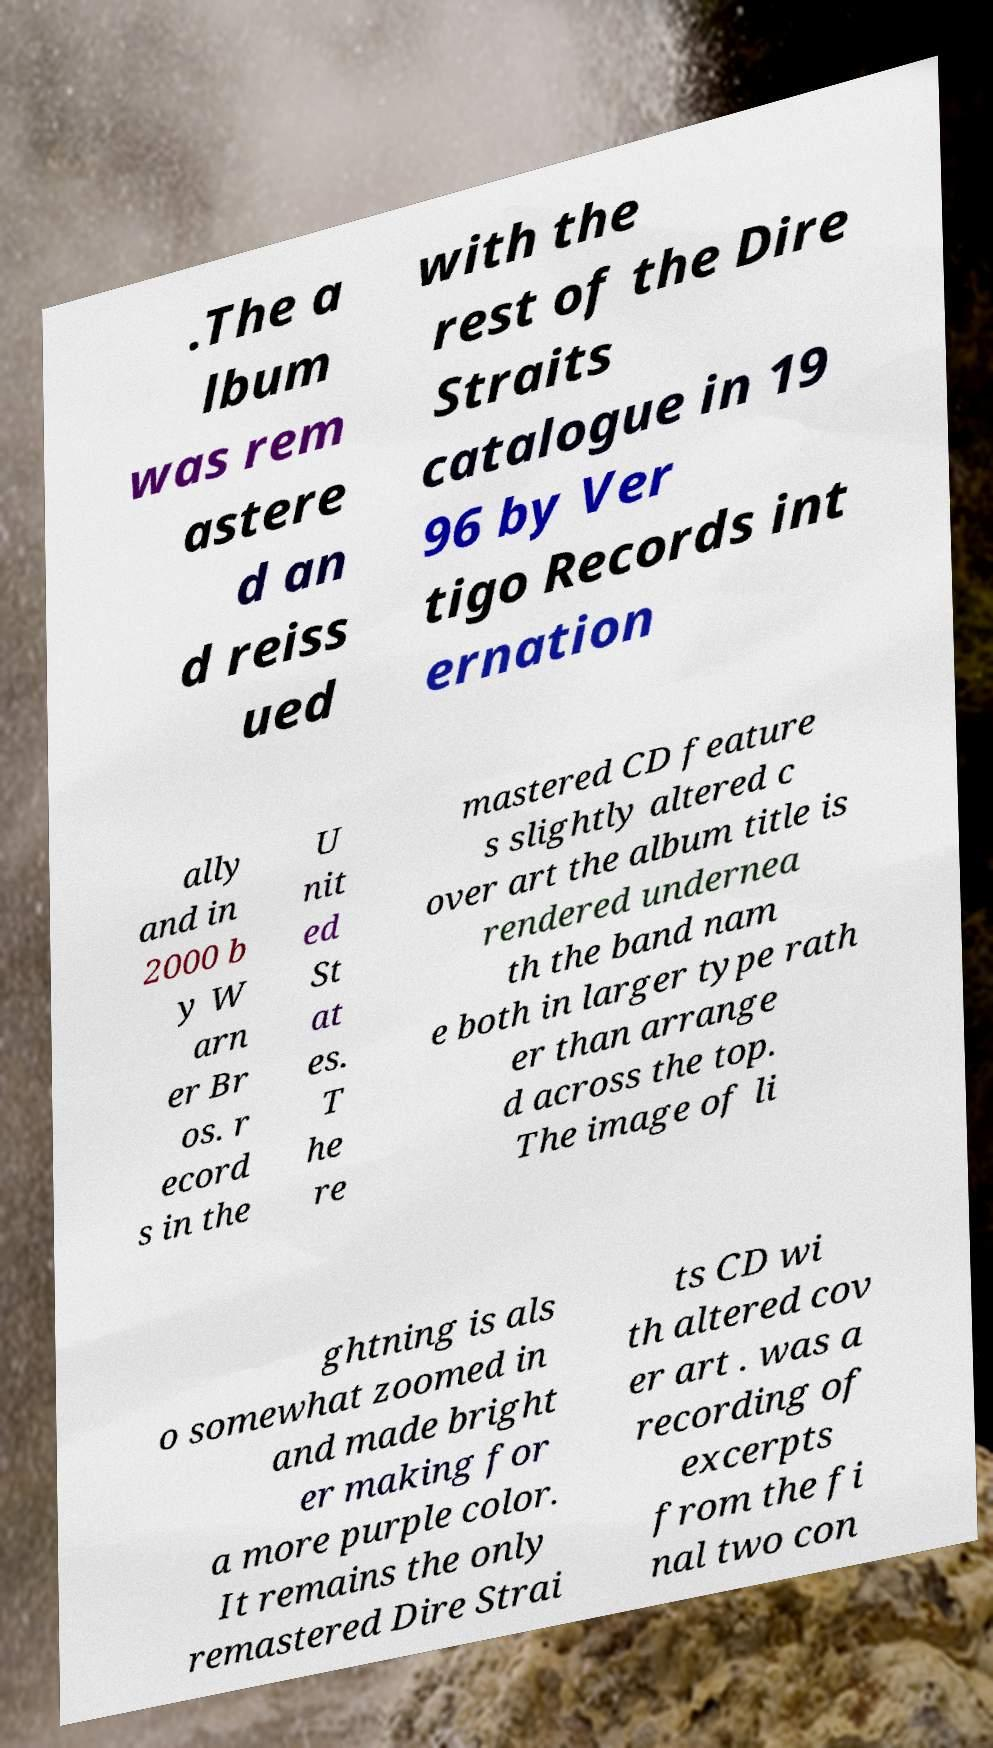Could you extract and type out the text from this image? .The a lbum was rem astere d an d reiss ued with the rest of the Dire Straits catalogue in 19 96 by Ver tigo Records int ernation ally and in 2000 b y W arn er Br os. r ecord s in the U nit ed St at es. T he re mastered CD feature s slightly altered c over art the album title is rendered undernea th the band nam e both in larger type rath er than arrange d across the top. The image of li ghtning is als o somewhat zoomed in and made bright er making for a more purple color. It remains the only remastered Dire Strai ts CD wi th altered cov er art . was a recording of excerpts from the fi nal two con 